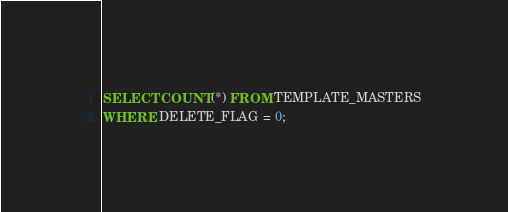<code> <loc_0><loc_0><loc_500><loc_500><_SQL_>SELECT COUNT(*) FROM TEMPLATE_MASTERS
WHERE DELETE_FLAG = 0;
</code> 